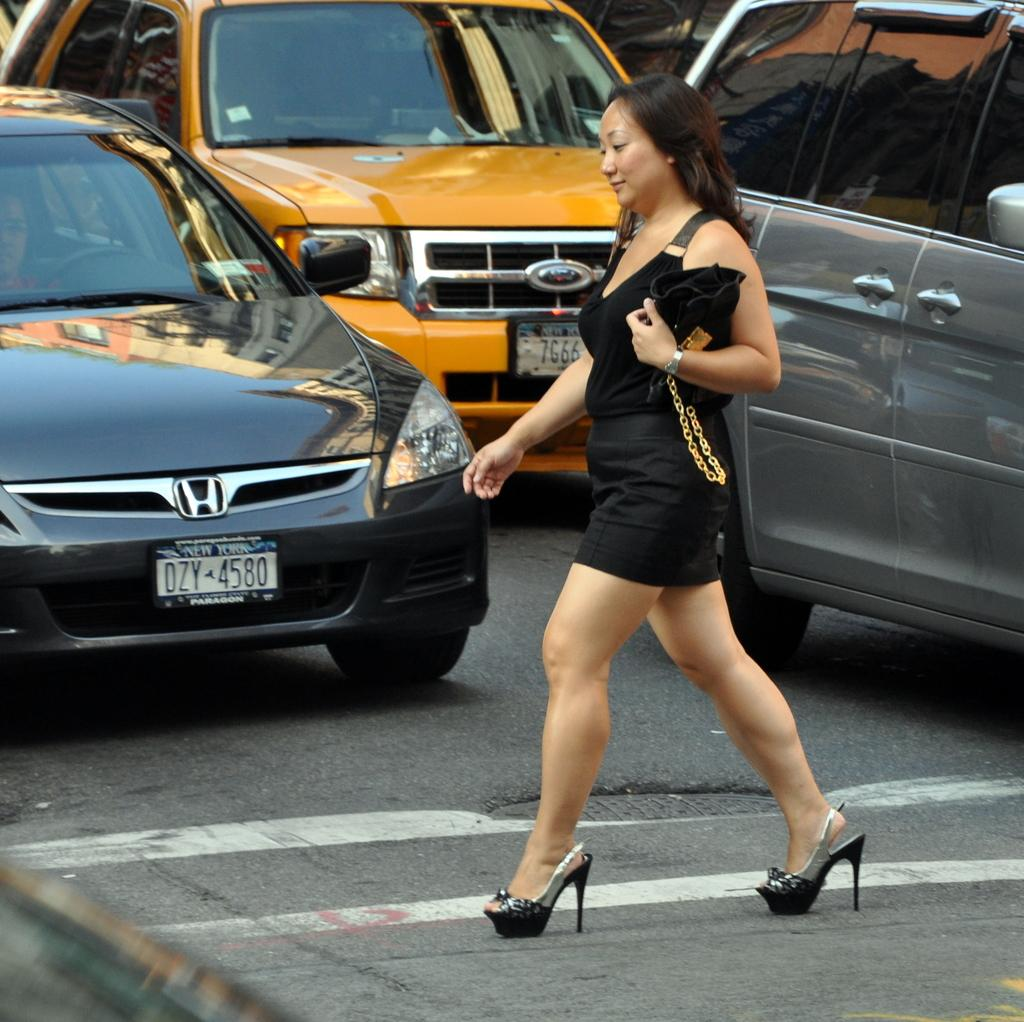Provide a one-sentence caption for the provided image. A woman crossing the street in front of a car with the license plate DZY 4580. 